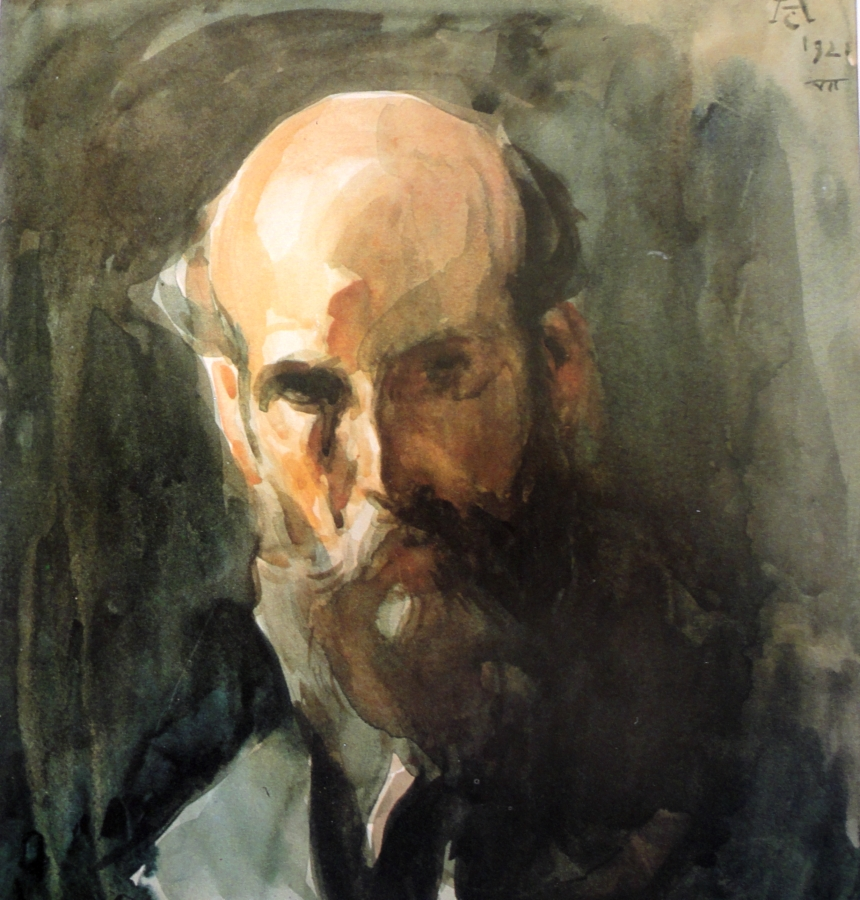Create a poem about this painting. In shadows deep, a face does lie,
Marked by years of asking, 'Why?'
Each stroke tells tales of days gone past,
In greens and browns, a story cast.
A solitary man with thoughts profound,
In silence deep, no spoken sound.
His eyes, they gaze through brush and paint,
A life of wisdom, without constraint. 